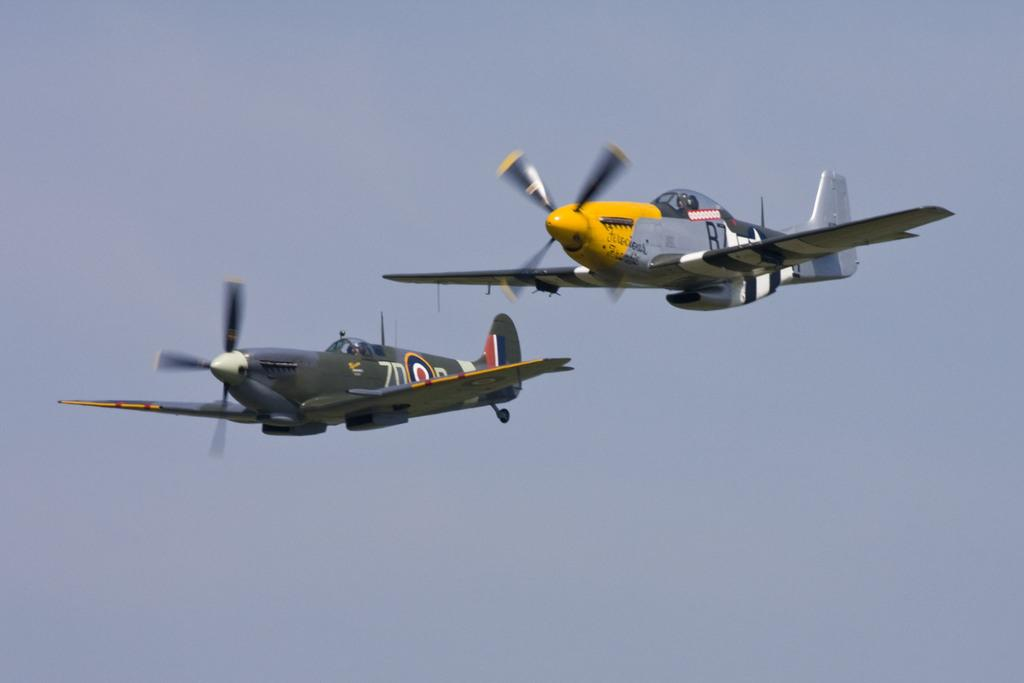<image>
Relay a brief, clear account of the picture shown. Two planes are flying in the air and the both have a letter and a seven on the side of them. 